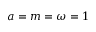<formula> <loc_0><loc_0><loc_500><loc_500>a = m = \omega = 1</formula> 